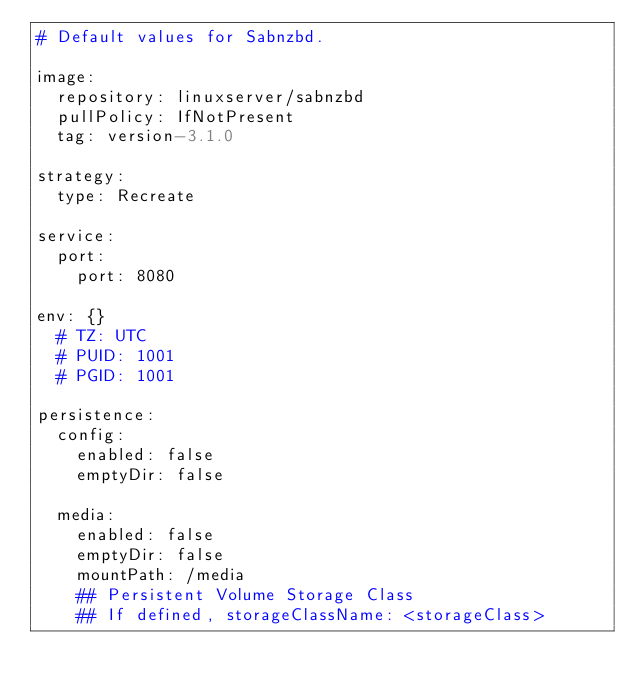<code> <loc_0><loc_0><loc_500><loc_500><_YAML_># Default values for Sabnzbd.

image:
  repository: linuxserver/sabnzbd
  pullPolicy: IfNotPresent
  tag: version-3.1.0

strategy:
  type: Recreate

service:
  port:
    port: 8080

env: {}
  # TZ: UTC
  # PUID: 1001
  # PGID: 1001

persistence:
  config:
    enabled: false
    emptyDir: false

  media:
    enabled: false
    emptyDir: false
    mountPath: /media
    ## Persistent Volume Storage Class
    ## If defined, storageClassName: <storageClass></code> 